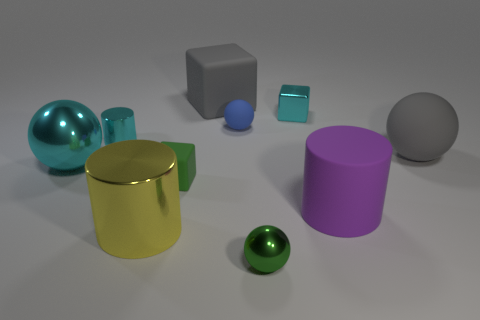Subtract all red balls. Subtract all gray cubes. How many balls are left? 4 Subtract all cylinders. How many objects are left? 7 Add 3 large brown cubes. How many large brown cubes exist? 3 Subtract 0 purple balls. How many objects are left? 10 Subtract all gray shiny cylinders. Subtract all matte cylinders. How many objects are left? 9 Add 4 rubber spheres. How many rubber spheres are left? 6 